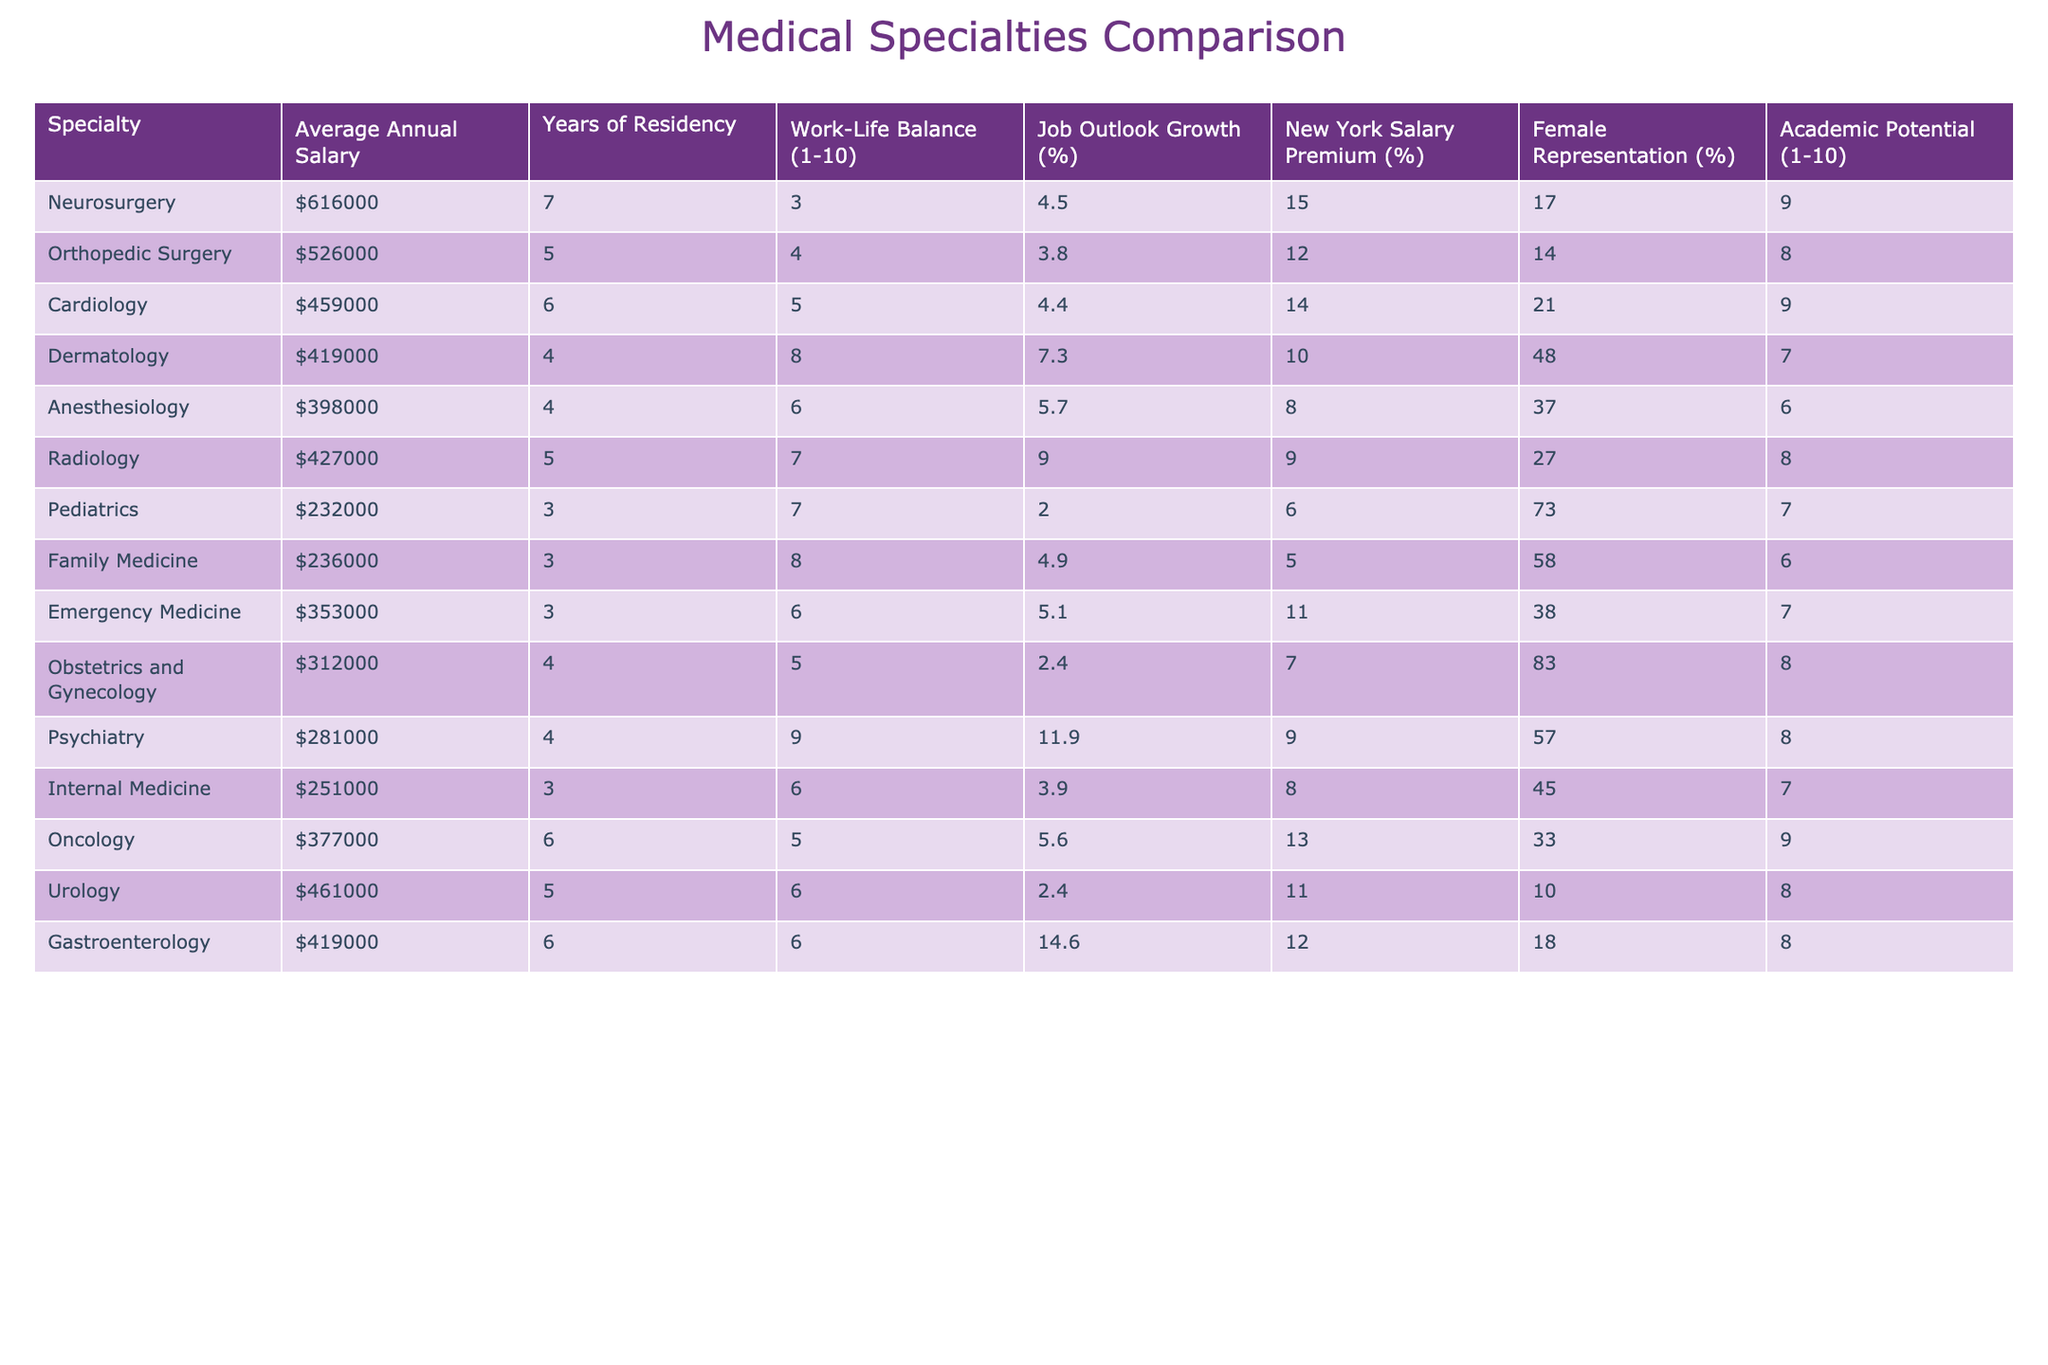What is the average annual salary of a Pediatrician? In the table, the salary for Pediatrics is listed as $232,000. This is a direct retrieval from the table.
Answer: $232,000 Which specialty has the highest average annual salary? The highest average annual salary is for Neurosurgery at $616,000, as identified from the salaries listed in the table.
Answer: Neurosurgery What is the average years of residency for an Anesthesiologist? The table shows that the years of residency for Anesthesiology is 4 years, which can be directly retrieved from the table.
Answer: 4 years How much higher is the average salary for Orthopedic Surgery compared to Internal Medicine? The average salary for Orthopedic Surgery is $526,000 and for Internal Medicine is $251,000. The difference is $526,000 - $251,000 = $275,000.
Answer: $275,000 What percentage of Cardiologists are female? The table indicates that female representation in Cardiology is 21%, which can be directly accessed from the data presented.
Answer: 21% Does Dermatology have a better work-life balance score than Anesthesiology? Dermatology has a work-life balance score of 8, while Anesthesiology has a score of 6. Since 8 > 6, we conclude that Dermatology is better in this aspect.
Answer: Yes Which specialty has the best job outlook growth percentage? In the table, Gastroenterology has the highest job outlook growth at 14.6%. This is retrieved by comparing the percentages in the job outlook growth column.
Answer: Gastroenterology How does the average salary of Urology compare to the average salary of Psychiatry? Urology has an average salary of $461,000 and Psychiatry has $281,000. The difference is $461,000 - $281,000 = $180,000, showing that Urology is higher.
Answer: Urology is $180,000 higher What is the median average annual salary of all listed specialties? To find the median, the salaries must first be sorted: $232,000, $236,000, $251,000, $281,000, $312,000, $353,000, $377,000, $398,000, $419,000, $419,000, $426,000, $459,000, $461,000, $526,000, $616,000. There are 15 salaries, so the median is the 8th value, which is $398,000.
Answer: $398,000 Is the average years of residency for Dermatology lower than that of Cardiology? Dermatology has 4 years while Cardiology has 6 years of residency. Since 4 < 6, the statement is true.
Answer: Yes 